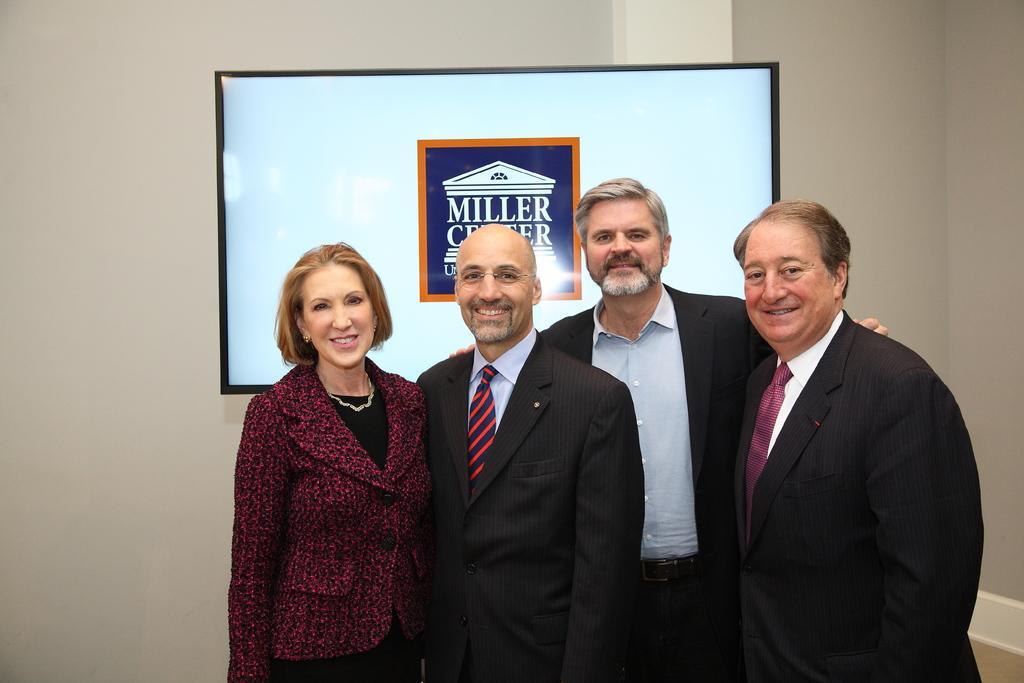How would you summarize this image in a sentence or two? In this image we can see persons standing on the floor. In the background we can see television and wall. 